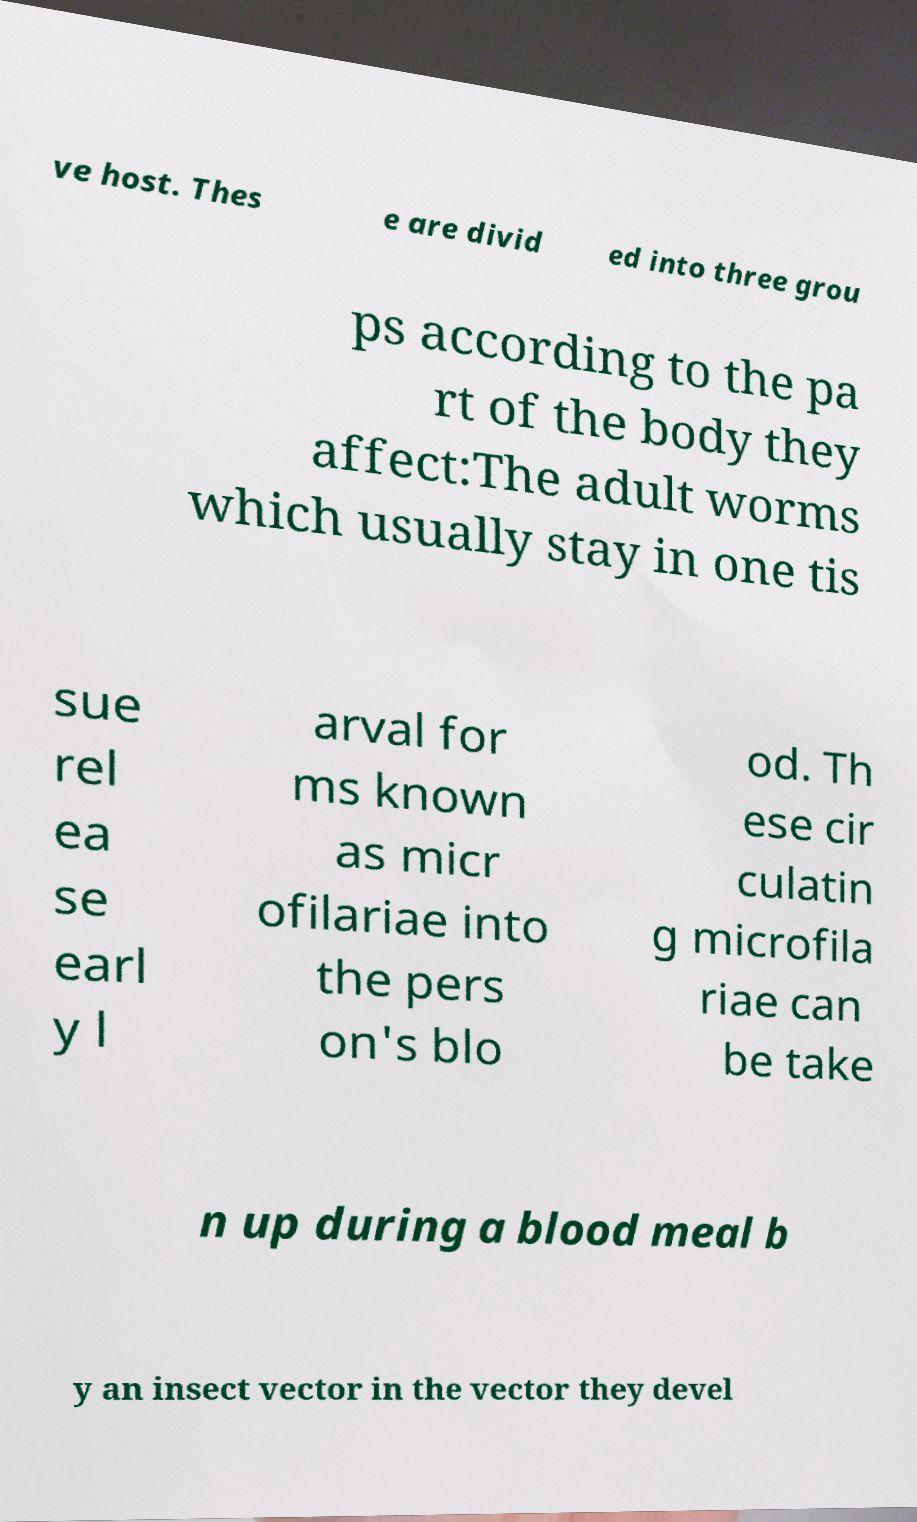There's text embedded in this image that I need extracted. Can you transcribe it verbatim? ve host. Thes e are divid ed into three grou ps according to the pa rt of the body they affect:The adult worms which usually stay in one tis sue rel ea se earl y l arval for ms known as micr ofilariae into the pers on's blo od. Th ese cir culatin g microfila riae can be take n up during a blood meal b y an insect vector in the vector they devel 